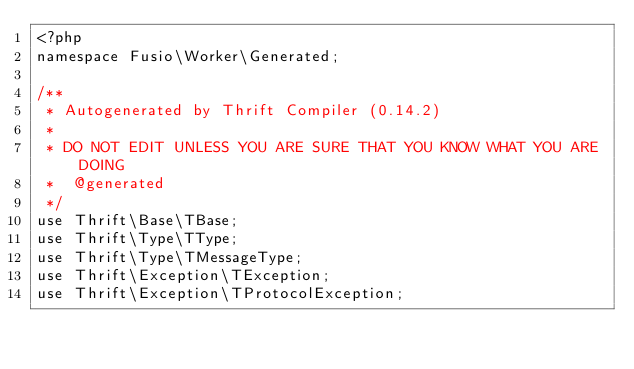Convert code to text. <code><loc_0><loc_0><loc_500><loc_500><_PHP_><?php
namespace Fusio\Worker\Generated;

/**
 * Autogenerated by Thrift Compiler (0.14.2)
 *
 * DO NOT EDIT UNLESS YOU ARE SURE THAT YOU KNOW WHAT YOU ARE DOING
 *  @generated
 */
use Thrift\Base\TBase;
use Thrift\Type\TType;
use Thrift\Type\TMessageType;
use Thrift\Exception\TException;
use Thrift\Exception\TProtocolException;</code> 